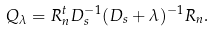<formula> <loc_0><loc_0><loc_500><loc_500>Q _ { \lambda } = R _ { n } ^ { t } D _ { s } ^ { - 1 } ( D _ { s } + \lambda ) ^ { - 1 } R _ { n } .</formula> 